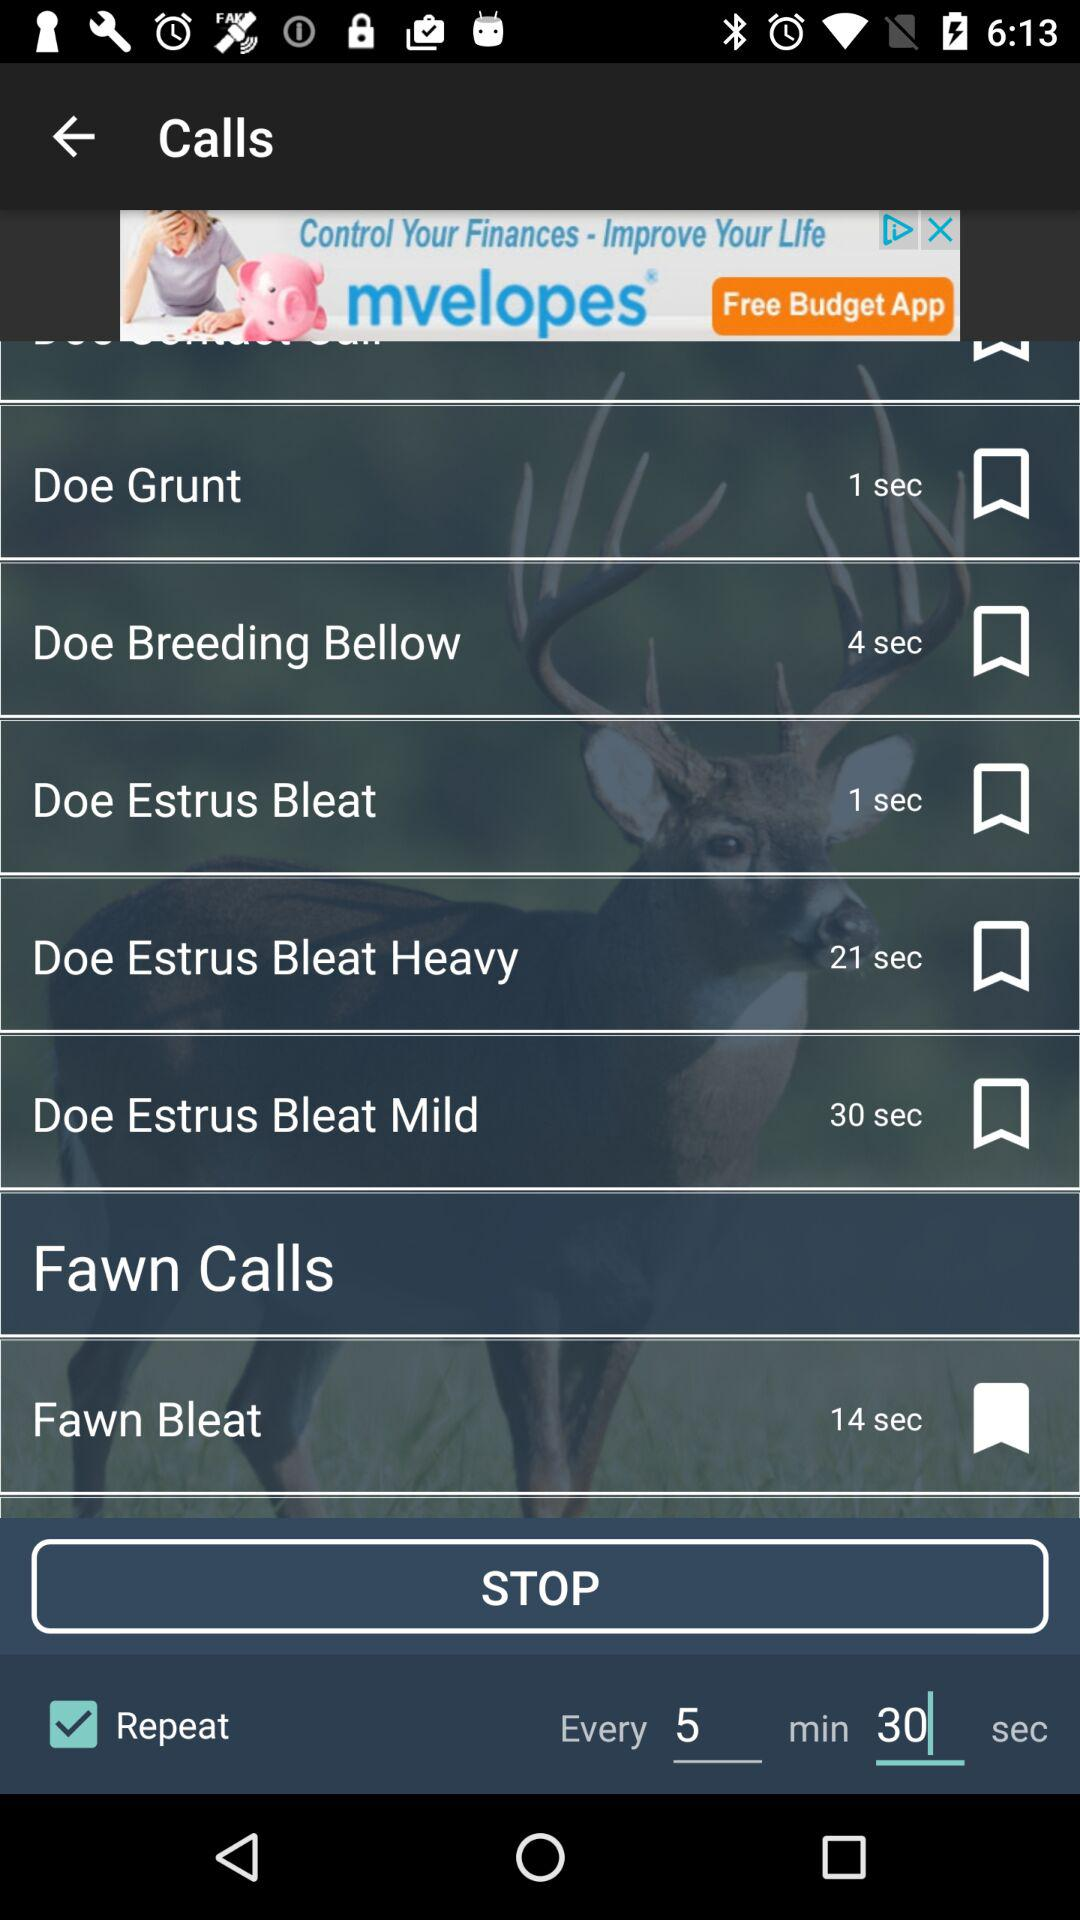What is the status of the repeat? The status of the repeat is on. 